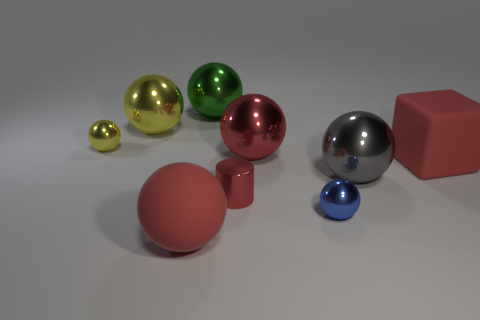Do the shiny cylinder and the block have the same color?
Give a very brief answer. Yes. What number of things are big matte objects that are right of the red rubber sphere or yellow shiny things?
Offer a terse response. 3. What is the shape of the yellow object that is the same size as the blue ball?
Make the answer very short. Sphere. Is the size of the matte thing that is behind the tiny red cylinder the same as the red object that is behind the large rubber cube?
Make the answer very short. Yes. What color is the cylinder that is the same material as the blue sphere?
Provide a succinct answer. Red. Do the small ball that is on the left side of the big red rubber ball and the large red sphere on the left side of the big green metallic ball have the same material?
Ensure brevity in your answer.  No. Is there a gray shiny sphere of the same size as the matte block?
Your answer should be very brief. Yes. There is a red rubber thing behind the big red object in front of the matte block; what size is it?
Offer a terse response. Large. What number of other cylinders have the same color as the metallic cylinder?
Make the answer very short. 0. There is a matte object right of the red object in front of the blue metallic thing; what shape is it?
Your answer should be very brief. Cube. 